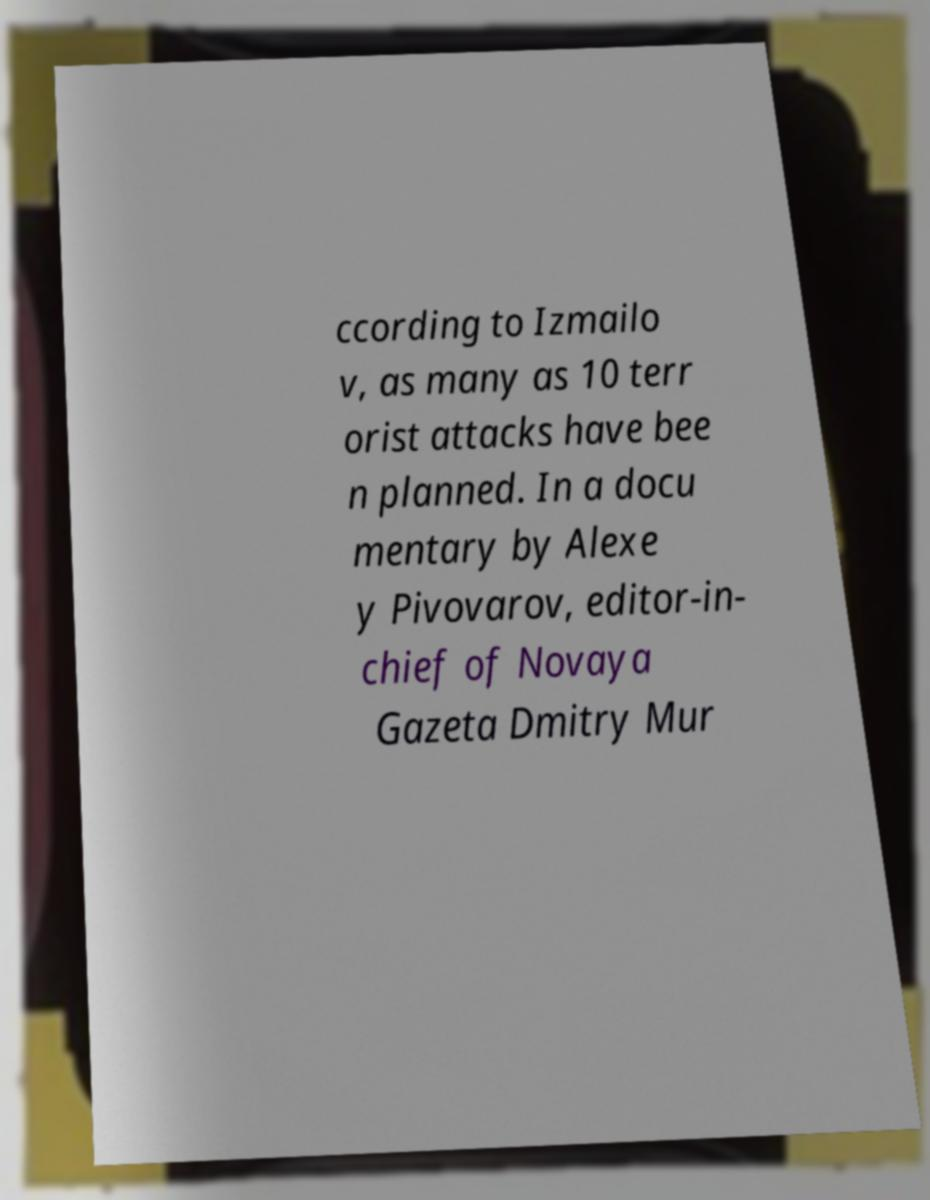Please read and relay the text visible in this image. What does it say? ccording to Izmailo v, as many as 10 terr orist attacks have bee n planned. In a docu mentary by Alexe y Pivovarov, editor-in- chief of Novaya Gazeta Dmitry Mur 